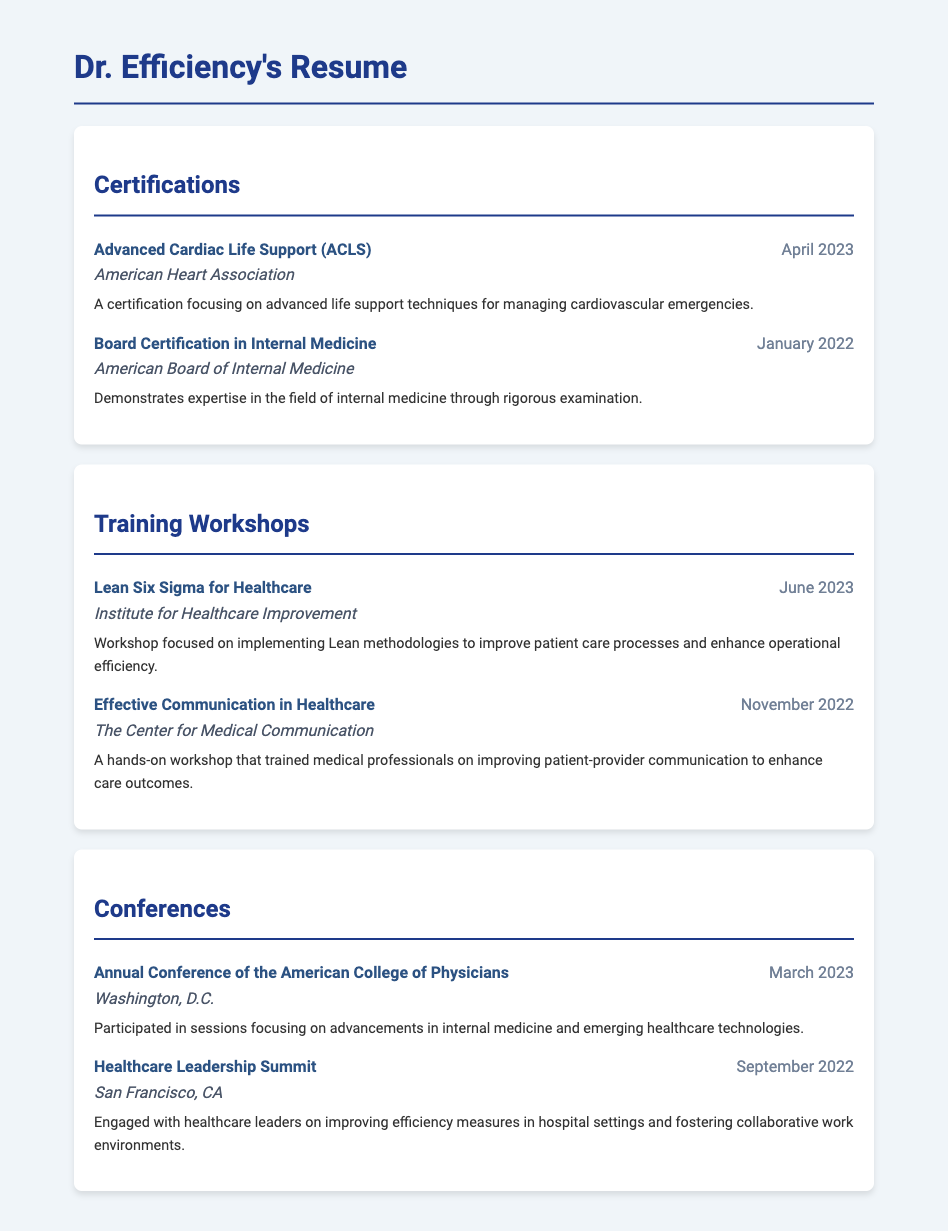What certification was obtained in April 2023? The certification obtained in April 2023 was Advanced Cardiac Life Support (ACLS).
Answer: Advanced Cardiac Life Support (ACLS) Who is the certifying body for Board Certification in Internal Medicine? The certifying body for Board Certification in Internal Medicine is the American Board of Internal Medicine.
Answer: American Board of Internal Medicine When did the workshop on Lean Six Sigma for Healthcare take place? The workshop on Lean Six Sigma for Healthcare took place in June 2023.
Answer: June 2023 What was the main focus of the Effective Communication in Healthcare workshop? The main focus was on improving patient-provider communication to enhance care outcomes.
Answer: Improving patient-provider communication How many conferences are detailed in the document? The document details two conferences.
Answer: Two Which conference took place in March 2023? The conference that took place in March 2023 was the Annual Conference of the American College of Physicians.
Answer: Annual Conference of the American College of Physicians What type of workshop was conducted by the Institute for Healthcare Improvement? The workshop conducted by the Institute for Healthcare Improvement was a Lean Six Sigma for Healthcare workshop.
Answer: Lean Six Sigma for Healthcare When was the Healthcare Leadership Summit held? The Healthcare Leadership Summit was held in September 2022.
Answer: September 2022 